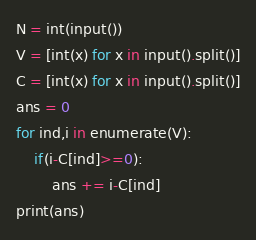<code> <loc_0><loc_0><loc_500><loc_500><_Python_>N = int(input())
V = [int(x) for x in input().split()]
C = [int(x) for x in input().split()]
ans = 0
for ind,i in enumerate(V):
    if(i-C[ind]>=0):
        ans += i-C[ind]
print(ans)
</code> 